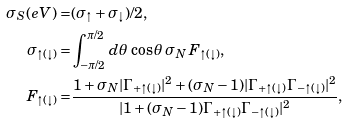<formula> <loc_0><loc_0><loc_500><loc_500>\sigma _ { S } ( e V ) = & ( \sigma _ { \uparrow } + \sigma _ { \downarrow } ) / 2 , \\ \sigma _ { \uparrow ( \downarrow ) } = & \int ^ { \pi / 2 } _ { - \pi / 2 } d \theta \, \cos \theta \, \sigma _ { N } \, F _ { \uparrow ( \downarrow ) } , \\ F _ { \uparrow ( \downarrow ) } = & \frac { 1 + \sigma _ { N } | \Gamma _ { + \uparrow ( \downarrow ) } | ^ { 2 } + ( \sigma _ { N } - 1 ) | \Gamma _ { + \uparrow ( \downarrow ) } \Gamma _ { - \uparrow ( \downarrow ) } | ^ { 2 } } { | 1 + ( \sigma _ { N } - 1 ) \Gamma _ { + \uparrow ( \downarrow ) } \Gamma _ { - \uparrow ( \downarrow ) } | ^ { 2 } } ,</formula> 